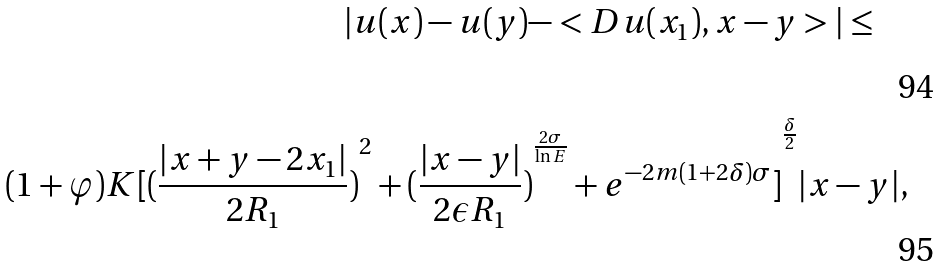Convert formula to latex. <formula><loc_0><loc_0><loc_500><loc_500>| u ( x ) - u ( y ) - < D u ( x _ { 1 } ) , x - y > | \leq \quad \\ ( 1 + \varphi ) K { [ { ( \frac { | x + y - 2 x _ { 1 } | } { 2 R _ { 1 } } ) } ^ { 2 } + { ( \frac { | x - y | } { 2 \epsilon R _ { 1 } } ) } ^ { \frac { 2 \sigma } { \ln E } } + e ^ { - 2 m ( 1 + 2 \delta ) \sigma } ] } ^ { \frac { \delta } { 2 } } | x - y | ,</formula> 